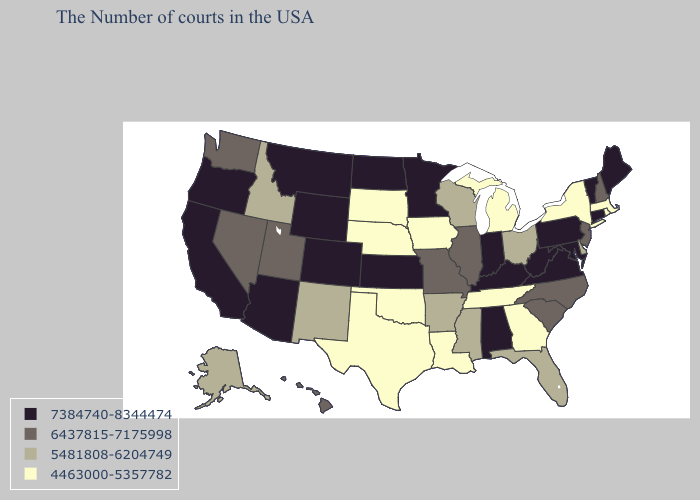Name the states that have a value in the range 4463000-5357782?
Quick response, please. Massachusetts, Rhode Island, New York, Georgia, Michigan, Tennessee, Louisiana, Iowa, Nebraska, Oklahoma, Texas, South Dakota. Name the states that have a value in the range 6437815-7175998?
Give a very brief answer. New Hampshire, New Jersey, North Carolina, South Carolina, Illinois, Missouri, Utah, Nevada, Washington, Hawaii. Which states have the lowest value in the USA?
Be succinct. Massachusetts, Rhode Island, New York, Georgia, Michigan, Tennessee, Louisiana, Iowa, Nebraska, Oklahoma, Texas, South Dakota. Does Colorado have the same value as Kentucky?
Concise answer only. Yes. Does Indiana have the lowest value in the MidWest?
Write a very short answer. No. What is the highest value in states that border Georgia?
Keep it brief. 7384740-8344474. Name the states that have a value in the range 4463000-5357782?
Quick response, please. Massachusetts, Rhode Island, New York, Georgia, Michigan, Tennessee, Louisiana, Iowa, Nebraska, Oklahoma, Texas, South Dakota. Which states have the highest value in the USA?
Quick response, please. Maine, Vermont, Connecticut, Maryland, Pennsylvania, Virginia, West Virginia, Kentucky, Indiana, Alabama, Minnesota, Kansas, North Dakota, Wyoming, Colorado, Montana, Arizona, California, Oregon. Name the states that have a value in the range 7384740-8344474?
Quick response, please. Maine, Vermont, Connecticut, Maryland, Pennsylvania, Virginia, West Virginia, Kentucky, Indiana, Alabama, Minnesota, Kansas, North Dakota, Wyoming, Colorado, Montana, Arizona, California, Oregon. Among the states that border Louisiana , which have the lowest value?
Give a very brief answer. Texas. Does Oklahoma have the highest value in the South?
Quick response, please. No. Does Kansas have the same value as Nevada?
Short answer required. No. Name the states that have a value in the range 5481808-6204749?
Answer briefly. Delaware, Ohio, Florida, Wisconsin, Mississippi, Arkansas, New Mexico, Idaho, Alaska. Does New Mexico have the lowest value in the West?
Keep it brief. Yes. Does the first symbol in the legend represent the smallest category?
Write a very short answer. No. 